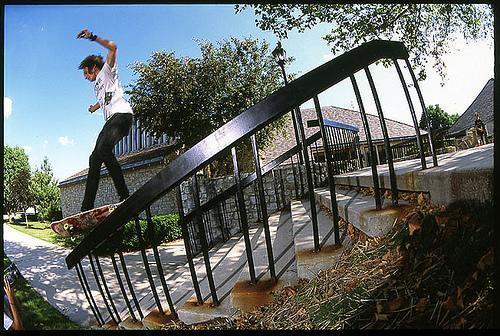How many big horse can be seen?
Give a very brief answer. 0. 